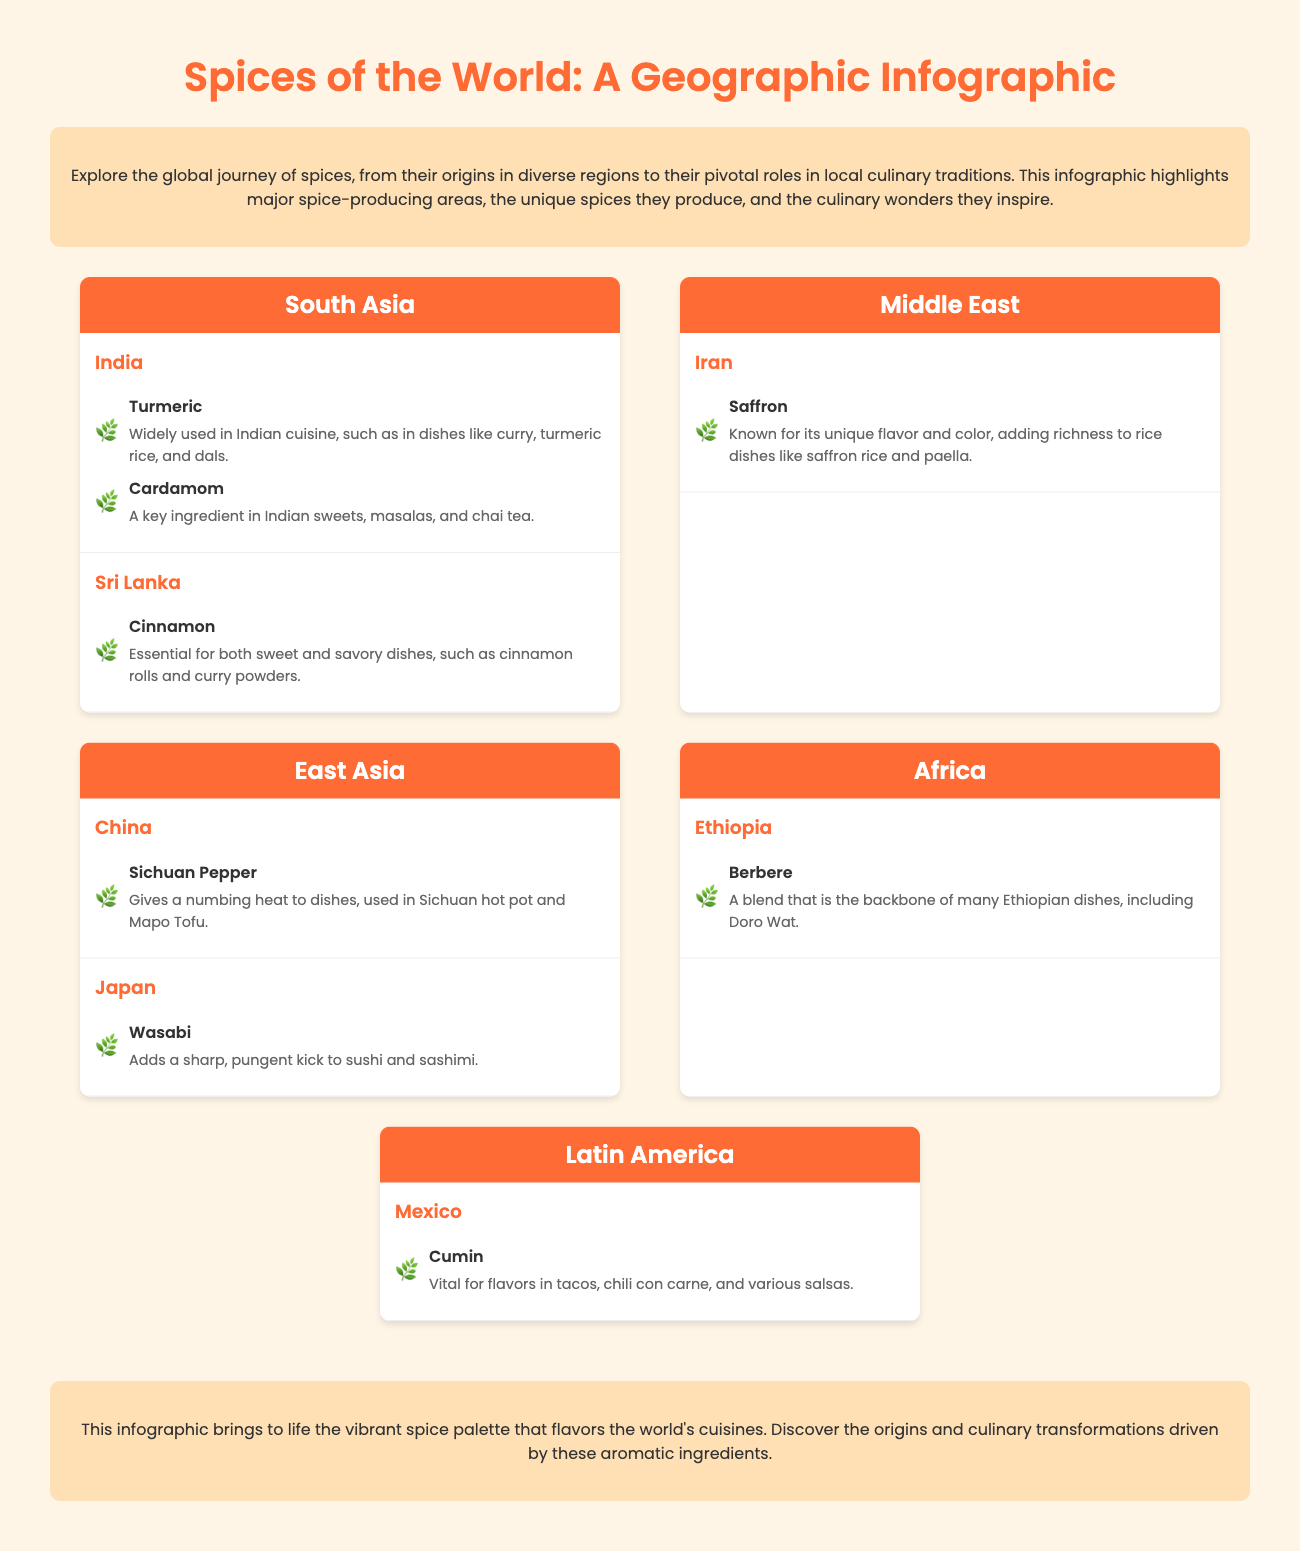What is the title of the infographic? The title of the infographic is prominently displayed at the top of the document.
Answer: Spices of the World: A Geographic Infographic Which spice is widely used in Indian cuisine? The infographic lists specific spices along with their origins and uses, highlighting turmeric as widely used in Indian dishes.
Answer: Turmeric What spice is known for adding richness to rice dishes in Iran? The infographic directly states that saffron is known for its unique flavor and color in rice dishes.
Answer: Saffron How many spice-producing countries are mentioned in South Asia? The document lists two countries in the South Asia region that produce spices, India and Sri Lanka.
Answer: 2 Which spice is vital for flavors in Mexican cuisine? The infographic indicates that cumin is a key spice used in various Mexican dishes.
Answer: Cumin What color palette is used for the infographic? The document describes using rich color palettes, primarily warm tones like orange and earthy shades.
Answer: Rich Color Palettes What is the unique impact of Sichuan pepper in Chinese cuisine? The infographic specifies that Sichuan pepper provides a numbing heat to dishes such as hot pot.
Answer: Numbing heat Which spice blend is the backbone of many Ethiopian dishes? The infographic states that berbere is essential to many Ethiopian recipes, including Doro Wat.
Answer: Berbere What is the main characteristic of wasabi? The infographic mentions wasabi adding a sharp, pungent kick to sushi and sashimi.
Answer: Sharp, pungent kick 